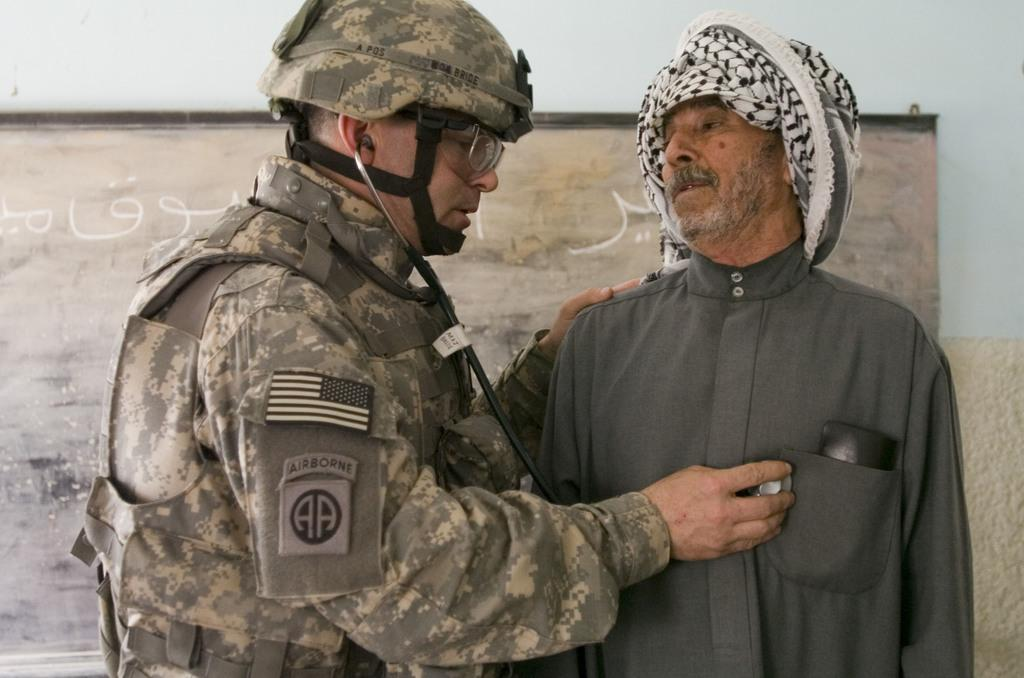How many people are in the image? There are two persons in the image. What is one person holding in the image? One person is holding a stethoscope. What can be seen on the wall in the background of the image? There is a board on the wall in the background of the image. What type of zephyr can be seen blowing through the image? There is no zephyr present in the image. What kind of marble is visible on the floor in the image? There is no marble visible in the image. 